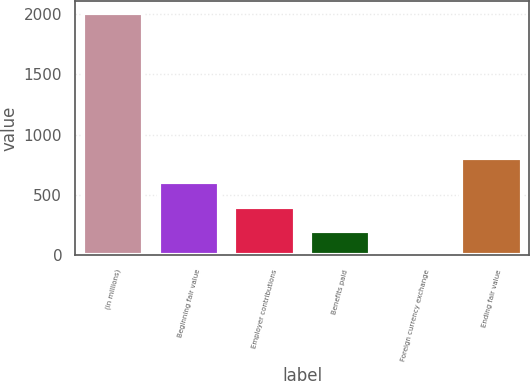<chart> <loc_0><loc_0><loc_500><loc_500><bar_chart><fcel>(in millions)<fcel>Beginning fair value<fcel>Employer contributions<fcel>Benefits paid<fcel>Foreign currency exchange<fcel>Ending fair value<nl><fcel>2012<fcel>605.7<fcel>404.8<fcel>203.9<fcel>3<fcel>806.6<nl></chart> 